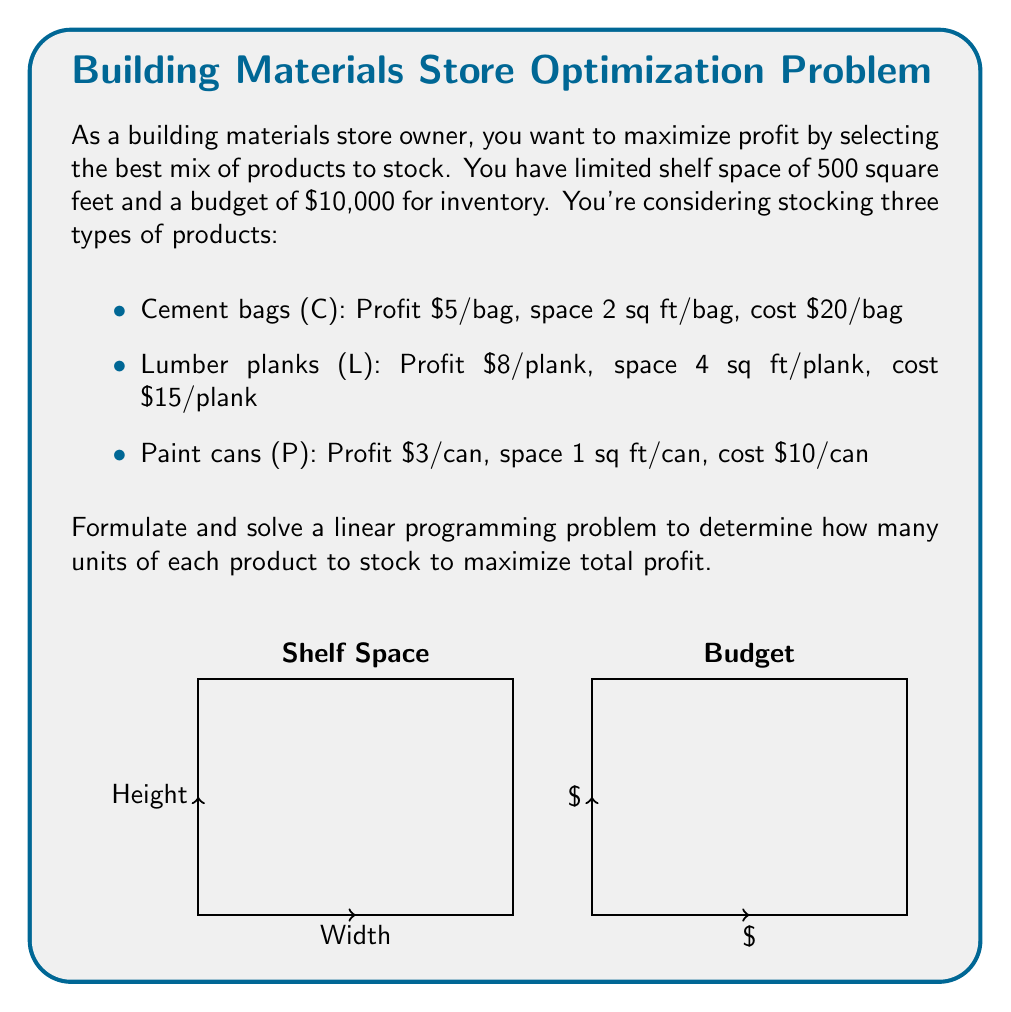Solve this math problem. Let's solve this linear programming problem step by step:

1) Define variables:
   Let $x_C$ = number of cement bags
   Let $x_L$ = number of lumber planks
   Let $x_P$ = number of paint cans

2) Objective function (maximize profit):
   $\text{Max } Z = 5x_C + 8x_L + 3x_P$

3) Constraints:
   a) Shelf space: $2x_C + 4x_L + x_P \leq 500$
   b) Budget: $20x_C + 15x_L + 10x_P \leq 10000$
   c) Non-negativity: $x_C, x_L, x_P \geq 0$

4) Solve using the simplex method or a linear programming solver.

5) The optimal solution is:
   $x_C = 125$ (cement bags)
   $x_L = 62.5$ (lumber planks)
   $x_P = 0$ (paint cans)

6) Maximum profit:
   $Z = 5(125) + 8(62.5) + 3(0) = 625 + 500 = 1125$

Therefore, to maximize profit, the store should stock 125 cement bags and 62 lumber planks (round down from 62.5), resulting in a maximum profit of $1,125.

Note: In practice, you would round down to 62 lumber planks due to the integer constraint for physical items.
Answer: Stock 125 cement bags and 62 lumber planks for a maximum profit of $1,125. 